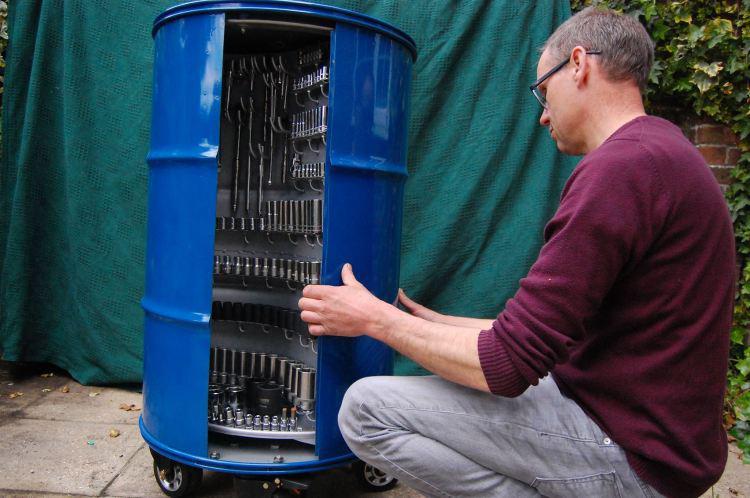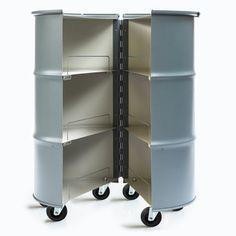The first image is the image on the left, the second image is the image on the right. Assess this claim about the two images: "The right image shows an empty barrel with a hinged opening, and the left image shows a tool-filled blue barrel with an open front.". Correct or not? Answer yes or no. Yes. The first image is the image on the left, the second image is the image on the right. For the images displayed, is the sentence "there is an empty drum open so the inside is viewable" factually correct? Answer yes or no. Yes. 